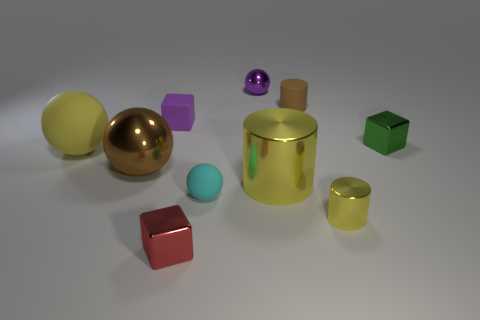How many tiny green blocks are behind the brown object that is behind the big yellow thing that is on the left side of the cyan sphere?
Your answer should be compact. 0. The other metal object that is the same shape as the large yellow shiny thing is what size?
Provide a succinct answer. Small. Is there anything else that is the same size as the brown rubber thing?
Your answer should be compact. Yes. Are there fewer red cubes to the right of the green metallic thing than small red shiny objects?
Provide a succinct answer. Yes. Is the shape of the tiny yellow shiny object the same as the red object?
Make the answer very short. No. There is a small matte thing that is the same shape as the red metallic object; what color is it?
Offer a terse response. Purple. How many tiny shiny blocks are the same color as the big metal sphere?
Provide a succinct answer. 0. What number of things are either tiny metal objects that are in front of the big yellow metal thing or small red matte objects?
Ensure brevity in your answer.  2. There is a cylinder that is behind the small green cube; what is its size?
Provide a succinct answer. Small. Is the number of small cyan spheres less than the number of tiny yellow rubber objects?
Your answer should be very brief. No. 